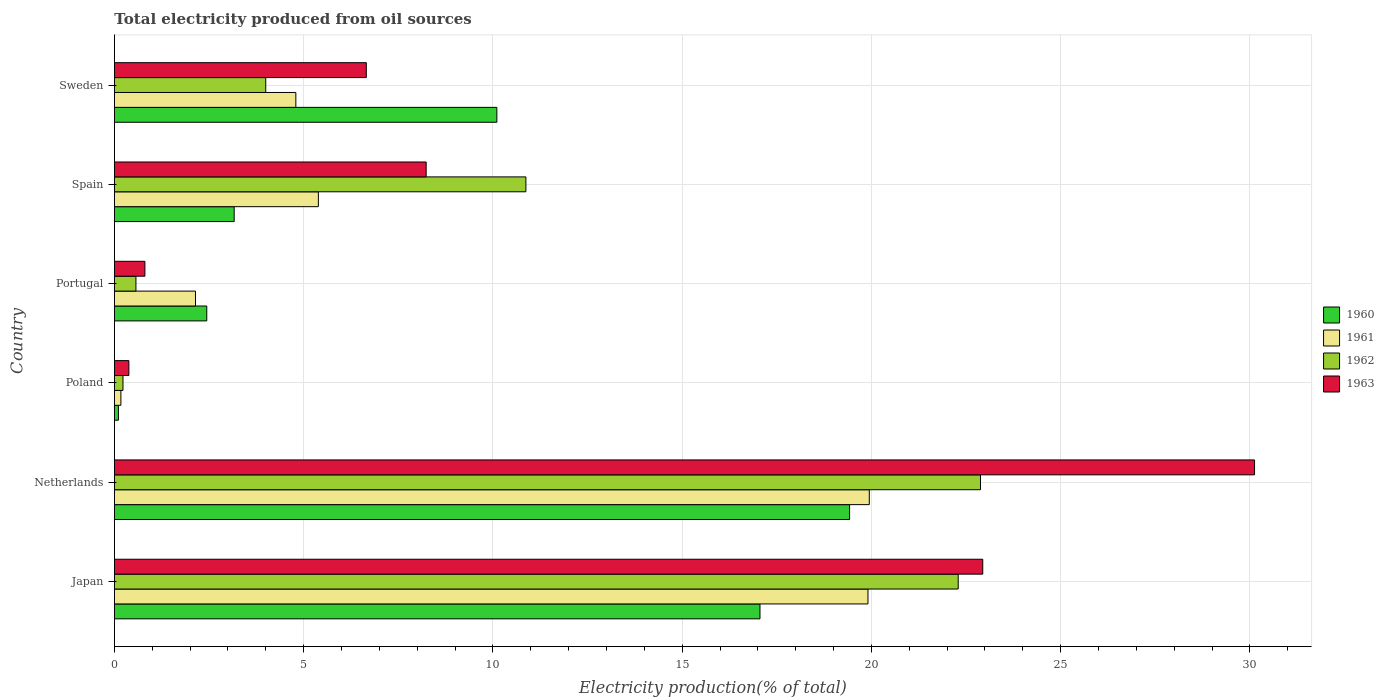How many different coloured bars are there?
Your response must be concise. 4. How many groups of bars are there?
Provide a short and direct response. 6. How many bars are there on the 4th tick from the top?
Give a very brief answer. 4. How many bars are there on the 2nd tick from the bottom?
Make the answer very short. 4. What is the label of the 4th group of bars from the top?
Keep it short and to the point. Poland. What is the total electricity produced in 1962 in Poland?
Your response must be concise. 0.23. Across all countries, what is the maximum total electricity produced in 1962?
Make the answer very short. 22.88. Across all countries, what is the minimum total electricity produced in 1962?
Give a very brief answer. 0.23. What is the total total electricity produced in 1960 in the graph?
Give a very brief answer. 52.29. What is the difference between the total electricity produced in 1960 in Netherlands and that in Portugal?
Keep it short and to the point. 16.98. What is the difference between the total electricity produced in 1963 in Japan and the total electricity produced in 1961 in Portugal?
Offer a very short reply. 20.8. What is the average total electricity produced in 1960 per country?
Offer a terse response. 8.72. What is the difference between the total electricity produced in 1962 and total electricity produced in 1963 in Spain?
Make the answer very short. 2.63. What is the ratio of the total electricity produced in 1962 in Japan to that in Portugal?
Provide a short and direct response. 39.24. Is the difference between the total electricity produced in 1962 in Japan and Portugal greater than the difference between the total electricity produced in 1963 in Japan and Portugal?
Your answer should be compact. No. What is the difference between the highest and the second highest total electricity produced in 1960?
Your answer should be compact. 2.37. What is the difference between the highest and the lowest total electricity produced in 1961?
Provide a short and direct response. 19.77. Is the sum of the total electricity produced in 1963 in Portugal and Spain greater than the maximum total electricity produced in 1962 across all countries?
Keep it short and to the point. No. Is it the case that in every country, the sum of the total electricity produced in 1962 and total electricity produced in 1961 is greater than the total electricity produced in 1960?
Ensure brevity in your answer.  No. How many bars are there?
Offer a terse response. 24. Are the values on the major ticks of X-axis written in scientific E-notation?
Your response must be concise. No. Does the graph contain any zero values?
Provide a short and direct response. No. Where does the legend appear in the graph?
Offer a very short reply. Center right. How many legend labels are there?
Give a very brief answer. 4. What is the title of the graph?
Your response must be concise. Total electricity produced from oil sources. What is the label or title of the Y-axis?
Your response must be concise. Country. What is the Electricity production(% of total) of 1960 in Japan?
Your answer should be compact. 17.06. What is the Electricity production(% of total) of 1961 in Japan?
Provide a succinct answer. 19.91. What is the Electricity production(% of total) of 1962 in Japan?
Provide a succinct answer. 22.29. What is the Electricity production(% of total) of 1963 in Japan?
Provide a short and direct response. 22.94. What is the Electricity production(% of total) in 1960 in Netherlands?
Your answer should be very brief. 19.42. What is the Electricity production(% of total) in 1961 in Netherlands?
Keep it short and to the point. 19.94. What is the Electricity production(% of total) in 1962 in Netherlands?
Ensure brevity in your answer.  22.88. What is the Electricity production(% of total) in 1963 in Netherlands?
Your answer should be compact. 30.12. What is the Electricity production(% of total) of 1960 in Poland?
Offer a very short reply. 0.11. What is the Electricity production(% of total) of 1961 in Poland?
Your answer should be very brief. 0.17. What is the Electricity production(% of total) in 1962 in Poland?
Keep it short and to the point. 0.23. What is the Electricity production(% of total) of 1963 in Poland?
Provide a succinct answer. 0.38. What is the Electricity production(% of total) of 1960 in Portugal?
Offer a terse response. 2.44. What is the Electricity production(% of total) in 1961 in Portugal?
Ensure brevity in your answer.  2.14. What is the Electricity production(% of total) of 1962 in Portugal?
Make the answer very short. 0.57. What is the Electricity production(% of total) in 1963 in Portugal?
Offer a very short reply. 0.81. What is the Electricity production(% of total) of 1960 in Spain?
Your answer should be very brief. 3.16. What is the Electricity production(% of total) of 1961 in Spain?
Provide a succinct answer. 5.39. What is the Electricity production(% of total) in 1962 in Spain?
Offer a terse response. 10.87. What is the Electricity production(% of total) in 1963 in Spain?
Your response must be concise. 8.24. What is the Electricity production(% of total) of 1960 in Sweden?
Provide a succinct answer. 10.1. What is the Electricity production(% of total) in 1961 in Sweden?
Make the answer very short. 4.79. What is the Electricity production(% of total) of 1962 in Sweden?
Give a very brief answer. 4. What is the Electricity production(% of total) of 1963 in Sweden?
Ensure brevity in your answer.  6.66. Across all countries, what is the maximum Electricity production(% of total) in 1960?
Your answer should be compact. 19.42. Across all countries, what is the maximum Electricity production(% of total) of 1961?
Give a very brief answer. 19.94. Across all countries, what is the maximum Electricity production(% of total) of 1962?
Keep it short and to the point. 22.88. Across all countries, what is the maximum Electricity production(% of total) in 1963?
Your answer should be compact. 30.12. Across all countries, what is the minimum Electricity production(% of total) of 1960?
Offer a terse response. 0.11. Across all countries, what is the minimum Electricity production(% of total) in 1961?
Your response must be concise. 0.17. Across all countries, what is the minimum Electricity production(% of total) of 1962?
Provide a short and direct response. 0.23. Across all countries, what is the minimum Electricity production(% of total) in 1963?
Provide a succinct answer. 0.38. What is the total Electricity production(% of total) of 1960 in the graph?
Your answer should be compact. 52.29. What is the total Electricity production(% of total) in 1961 in the graph?
Your response must be concise. 52.35. What is the total Electricity production(% of total) of 1962 in the graph?
Provide a short and direct response. 60.84. What is the total Electricity production(% of total) in 1963 in the graph?
Your answer should be compact. 69.14. What is the difference between the Electricity production(% of total) in 1960 in Japan and that in Netherlands?
Offer a terse response. -2.37. What is the difference between the Electricity production(% of total) of 1961 in Japan and that in Netherlands?
Your response must be concise. -0.04. What is the difference between the Electricity production(% of total) in 1962 in Japan and that in Netherlands?
Your response must be concise. -0.59. What is the difference between the Electricity production(% of total) of 1963 in Japan and that in Netherlands?
Your response must be concise. -7.18. What is the difference between the Electricity production(% of total) in 1960 in Japan and that in Poland?
Ensure brevity in your answer.  16.95. What is the difference between the Electricity production(% of total) in 1961 in Japan and that in Poland?
Offer a terse response. 19.74. What is the difference between the Electricity production(% of total) of 1962 in Japan and that in Poland?
Ensure brevity in your answer.  22.07. What is the difference between the Electricity production(% of total) of 1963 in Japan and that in Poland?
Ensure brevity in your answer.  22.56. What is the difference between the Electricity production(% of total) in 1960 in Japan and that in Portugal?
Ensure brevity in your answer.  14.62. What is the difference between the Electricity production(% of total) in 1961 in Japan and that in Portugal?
Give a very brief answer. 17.77. What is the difference between the Electricity production(% of total) of 1962 in Japan and that in Portugal?
Your response must be concise. 21.73. What is the difference between the Electricity production(% of total) of 1963 in Japan and that in Portugal?
Offer a terse response. 22.14. What is the difference between the Electricity production(% of total) in 1960 in Japan and that in Spain?
Your answer should be very brief. 13.89. What is the difference between the Electricity production(% of total) of 1961 in Japan and that in Spain?
Give a very brief answer. 14.52. What is the difference between the Electricity production(% of total) in 1962 in Japan and that in Spain?
Offer a very short reply. 11.42. What is the difference between the Electricity production(% of total) in 1963 in Japan and that in Spain?
Your answer should be very brief. 14.71. What is the difference between the Electricity production(% of total) in 1960 in Japan and that in Sweden?
Offer a very short reply. 6.95. What is the difference between the Electricity production(% of total) of 1961 in Japan and that in Sweden?
Your response must be concise. 15.12. What is the difference between the Electricity production(% of total) of 1962 in Japan and that in Sweden?
Provide a short and direct response. 18.3. What is the difference between the Electricity production(% of total) in 1963 in Japan and that in Sweden?
Your answer should be very brief. 16.29. What is the difference between the Electricity production(% of total) in 1960 in Netherlands and that in Poland?
Keep it short and to the point. 19.32. What is the difference between the Electricity production(% of total) in 1961 in Netherlands and that in Poland?
Provide a succinct answer. 19.77. What is the difference between the Electricity production(% of total) in 1962 in Netherlands and that in Poland?
Your answer should be compact. 22.66. What is the difference between the Electricity production(% of total) in 1963 in Netherlands and that in Poland?
Provide a succinct answer. 29.74. What is the difference between the Electricity production(% of total) of 1960 in Netherlands and that in Portugal?
Your answer should be compact. 16.98. What is the difference between the Electricity production(% of total) in 1961 in Netherlands and that in Portugal?
Make the answer very short. 17.8. What is the difference between the Electricity production(% of total) in 1962 in Netherlands and that in Portugal?
Give a very brief answer. 22.31. What is the difference between the Electricity production(% of total) in 1963 in Netherlands and that in Portugal?
Offer a terse response. 29.32. What is the difference between the Electricity production(% of total) in 1960 in Netherlands and that in Spain?
Offer a very short reply. 16.26. What is the difference between the Electricity production(% of total) in 1961 in Netherlands and that in Spain?
Offer a very short reply. 14.56. What is the difference between the Electricity production(% of total) in 1962 in Netherlands and that in Spain?
Offer a very short reply. 12.01. What is the difference between the Electricity production(% of total) of 1963 in Netherlands and that in Spain?
Your answer should be compact. 21.89. What is the difference between the Electricity production(% of total) in 1960 in Netherlands and that in Sweden?
Give a very brief answer. 9.32. What is the difference between the Electricity production(% of total) of 1961 in Netherlands and that in Sweden?
Offer a terse response. 15.15. What is the difference between the Electricity production(% of total) of 1962 in Netherlands and that in Sweden?
Your response must be concise. 18.88. What is the difference between the Electricity production(% of total) in 1963 in Netherlands and that in Sweden?
Offer a terse response. 23.47. What is the difference between the Electricity production(% of total) of 1960 in Poland and that in Portugal?
Your answer should be compact. -2.33. What is the difference between the Electricity production(% of total) of 1961 in Poland and that in Portugal?
Provide a succinct answer. -1.97. What is the difference between the Electricity production(% of total) in 1962 in Poland and that in Portugal?
Provide a succinct answer. -0.34. What is the difference between the Electricity production(% of total) in 1963 in Poland and that in Portugal?
Ensure brevity in your answer.  -0.42. What is the difference between the Electricity production(% of total) in 1960 in Poland and that in Spain?
Your response must be concise. -3.06. What is the difference between the Electricity production(% of total) in 1961 in Poland and that in Spain?
Give a very brief answer. -5.22. What is the difference between the Electricity production(% of total) of 1962 in Poland and that in Spain?
Your answer should be compact. -10.64. What is the difference between the Electricity production(% of total) in 1963 in Poland and that in Spain?
Provide a short and direct response. -7.85. What is the difference between the Electricity production(% of total) in 1960 in Poland and that in Sweden?
Your answer should be very brief. -10. What is the difference between the Electricity production(% of total) of 1961 in Poland and that in Sweden?
Give a very brief answer. -4.62. What is the difference between the Electricity production(% of total) of 1962 in Poland and that in Sweden?
Your answer should be compact. -3.77. What is the difference between the Electricity production(% of total) in 1963 in Poland and that in Sweden?
Offer a terse response. -6.27. What is the difference between the Electricity production(% of total) in 1960 in Portugal and that in Spain?
Ensure brevity in your answer.  -0.72. What is the difference between the Electricity production(% of total) in 1961 in Portugal and that in Spain?
Offer a very short reply. -3.25. What is the difference between the Electricity production(% of total) in 1962 in Portugal and that in Spain?
Provide a short and direct response. -10.3. What is the difference between the Electricity production(% of total) in 1963 in Portugal and that in Spain?
Your answer should be very brief. -7.43. What is the difference between the Electricity production(% of total) in 1960 in Portugal and that in Sweden?
Provide a succinct answer. -7.66. What is the difference between the Electricity production(% of total) in 1961 in Portugal and that in Sweden?
Your answer should be compact. -2.65. What is the difference between the Electricity production(% of total) in 1962 in Portugal and that in Sweden?
Give a very brief answer. -3.43. What is the difference between the Electricity production(% of total) in 1963 in Portugal and that in Sweden?
Offer a very short reply. -5.85. What is the difference between the Electricity production(% of total) in 1960 in Spain and that in Sweden?
Make the answer very short. -6.94. What is the difference between the Electricity production(% of total) in 1961 in Spain and that in Sweden?
Your answer should be very brief. 0.6. What is the difference between the Electricity production(% of total) in 1962 in Spain and that in Sweden?
Give a very brief answer. 6.87. What is the difference between the Electricity production(% of total) in 1963 in Spain and that in Sweden?
Ensure brevity in your answer.  1.58. What is the difference between the Electricity production(% of total) in 1960 in Japan and the Electricity production(% of total) in 1961 in Netherlands?
Offer a very short reply. -2.89. What is the difference between the Electricity production(% of total) of 1960 in Japan and the Electricity production(% of total) of 1962 in Netherlands?
Offer a very short reply. -5.83. What is the difference between the Electricity production(% of total) in 1960 in Japan and the Electricity production(% of total) in 1963 in Netherlands?
Your answer should be very brief. -13.07. What is the difference between the Electricity production(% of total) in 1961 in Japan and the Electricity production(% of total) in 1962 in Netherlands?
Ensure brevity in your answer.  -2.97. What is the difference between the Electricity production(% of total) in 1961 in Japan and the Electricity production(% of total) in 1963 in Netherlands?
Offer a very short reply. -10.21. What is the difference between the Electricity production(% of total) of 1962 in Japan and the Electricity production(% of total) of 1963 in Netherlands?
Your answer should be very brief. -7.83. What is the difference between the Electricity production(% of total) of 1960 in Japan and the Electricity production(% of total) of 1961 in Poland?
Your answer should be compact. 16.89. What is the difference between the Electricity production(% of total) of 1960 in Japan and the Electricity production(% of total) of 1962 in Poland?
Keep it short and to the point. 16.83. What is the difference between the Electricity production(% of total) of 1960 in Japan and the Electricity production(% of total) of 1963 in Poland?
Provide a short and direct response. 16.67. What is the difference between the Electricity production(% of total) in 1961 in Japan and the Electricity production(% of total) in 1962 in Poland?
Your answer should be very brief. 19.68. What is the difference between the Electricity production(% of total) of 1961 in Japan and the Electricity production(% of total) of 1963 in Poland?
Your answer should be compact. 19.53. What is the difference between the Electricity production(% of total) in 1962 in Japan and the Electricity production(% of total) in 1963 in Poland?
Make the answer very short. 21.91. What is the difference between the Electricity production(% of total) in 1960 in Japan and the Electricity production(% of total) in 1961 in Portugal?
Keep it short and to the point. 14.91. What is the difference between the Electricity production(% of total) of 1960 in Japan and the Electricity production(% of total) of 1962 in Portugal?
Provide a short and direct response. 16.49. What is the difference between the Electricity production(% of total) in 1960 in Japan and the Electricity production(% of total) in 1963 in Portugal?
Ensure brevity in your answer.  16.25. What is the difference between the Electricity production(% of total) of 1961 in Japan and the Electricity production(% of total) of 1962 in Portugal?
Provide a succinct answer. 19.34. What is the difference between the Electricity production(% of total) of 1961 in Japan and the Electricity production(% of total) of 1963 in Portugal?
Provide a succinct answer. 19.1. What is the difference between the Electricity production(% of total) in 1962 in Japan and the Electricity production(% of total) in 1963 in Portugal?
Your answer should be compact. 21.49. What is the difference between the Electricity production(% of total) in 1960 in Japan and the Electricity production(% of total) in 1961 in Spain?
Keep it short and to the point. 11.67. What is the difference between the Electricity production(% of total) of 1960 in Japan and the Electricity production(% of total) of 1962 in Spain?
Ensure brevity in your answer.  6.19. What is the difference between the Electricity production(% of total) in 1960 in Japan and the Electricity production(% of total) in 1963 in Spain?
Your answer should be compact. 8.82. What is the difference between the Electricity production(% of total) in 1961 in Japan and the Electricity production(% of total) in 1962 in Spain?
Make the answer very short. 9.04. What is the difference between the Electricity production(% of total) of 1961 in Japan and the Electricity production(% of total) of 1963 in Spain?
Give a very brief answer. 11.67. What is the difference between the Electricity production(% of total) in 1962 in Japan and the Electricity production(% of total) in 1963 in Spain?
Provide a short and direct response. 14.06. What is the difference between the Electricity production(% of total) of 1960 in Japan and the Electricity production(% of total) of 1961 in Sweden?
Your answer should be compact. 12.26. What is the difference between the Electricity production(% of total) of 1960 in Japan and the Electricity production(% of total) of 1962 in Sweden?
Provide a succinct answer. 13.06. What is the difference between the Electricity production(% of total) in 1960 in Japan and the Electricity production(% of total) in 1963 in Sweden?
Your answer should be compact. 10.4. What is the difference between the Electricity production(% of total) of 1961 in Japan and the Electricity production(% of total) of 1962 in Sweden?
Your answer should be very brief. 15.91. What is the difference between the Electricity production(% of total) in 1961 in Japan and the Electricity production(% of total) in 1963 in Sweden?
Your answer should be very brief. 13.25. What is the difference between the Electricity production(% of total) of 1962 in Japan and the Electricity production(% of total) of 1963 in Sweden?
Provide a succinct answer. 15.64. What is the difference between the Electricity production(% of total) of 1960 in Netherlands and the Electricity production(% of total) of 1961 in Poland?
Offer a very short reply. 19.25. What is the difference between the Electricity production(% of total) in 1960 in Netherlands and the Electricity production(% of total) in 1962 in Poland?
Give a very brief answer. 19.2. What is the difference between the Electricity production(% of total) of 1960 in Netherlands and the Electricity production(% of total) of 1963 in Poland?
Make the answer very short. 19.04. What is the difference between the Electricity production(% of total) of 1961 in Netherlands and the Electricity production(% of total) of 1962 in Poland?
Ensure brevity in your answer.  19.72. What is the difference between the Electricity production(% of total) of 1961 in Netherlands and the Electricity production(% of total) of 1963 in Poland?
Your answer should be very brief. 19.56. What is the difference between the Electricity production(% of total) in 1962 in Netherlands and the Electricity production(% of total) in 1963 in Poland?
Your answer should be very brief. 22.5. What is the difference between the Electricity production(% of total) of 1960 in Netherlands and the Electricity production(% of total) of 1961 in Portugal?
Provide a succinct answer. 17.28. What is the difference between the Electricity production(% of total) of 1960 in Netherlands and the Electricity production(% of total) of 1962 in Portugal?
Provide a succinct answer. 18.86. What is the difference between the Electricity production(% of total) of 1960 in Netherlands and the Electricity production(% of total) of 1963 in Portugal?
Keep it short and to the point. 18.62. What is the difference between the Electricity production(% of total) of 1961 in Netherlands and the Electricity production(% of total) of 1962 in Portugal?
Provide a succinct answer. 19.38. What is the difference between the Electricity production(% of total) in 1961 in Netherlands and the Electricity production(% of total) in 1963 in Portugal?
Your answer should be very brief. 19.14. What is the difference between the Electricity production(% of total) in 1962 in Netherlands and the Electricity production(% of total) in 1963 in Portugal?
Offer a very short reply. 22.08. What is the difference between the Electricity production(% of total) of 1960 in Netherlands and the Electricity production(% of total) of 1961 in Spain?
Your answer should be compact. 14.04. What is the difference between the Electricity production(% of total) of 1960 in Netherlands and the Electricity production(% of total) of 1962 in Spain?
Ensure brevity in your answer.  8.55. What is the difference between the Electricity production(% of total) of 1960 in Netherlands and the Electricity production(% of total) of 1963 in Spain?
Your answer should be very brief. 11.19. What is the difference between the Electricity production(% of total) of 1961 in Netherlands and the Electricity production(% of total) of 1962 in Spain?
Your answer should be compact. 9.07. What is the difference between the Electricity production(% of total) in 1961 in Netherlands and the Electricity production(% of total) in 1963 in Spain?
Provide a short and direct response. 11.71. What is the difference between the Electricity production(% of total) in 1962 in Netherlands and the Electricity production(% of total) in 1963 in Spain?
Give a very brief answer. 14.65. What is the difference between the Electricity production(% of total) of 1960 in Netherlands and the Electricity production(% of total) of 1961 in Sweden?
Provide a succinct answer. 14.63. What is the difference between the Electricity production(% of total) of 1960 in Netherlands and the Electricity production(% of total) of 1962 in Sweden?
Your answer should be very brief. 15.43. What is the difference between the Electricity production(% of total) of 1960 in Netherlands and the Electricity production(% of total) of 1963 in Sweden?
Give a very brief answer. 12.77. What is the difference between the Electricity production(% of total) in 1961 in Netherlands and the Electricity production(% of total) in 1962 in Sweden?
Your answer should be very brief. 15.95. What is the difference between the Electricity production(% of total) of 1961 in Netherlands and the Electricity production(% of total) of 1963 in Sweden?
Offer a terse response. 13.29. What is the difference between the Electricity production(% of total) in 1962 in Netherlands and the Electricity production(% of total) in 1963 in Sweden?
Give a very brief answer. 16.23. What is the difference between the Electricity production(% of total) in 1960 in Poland and the Electricity production(% of total) in 1961 in Portugal?
Keep it short and to the point. -2.04. What is the difference between the Electricity production(% of total) in 1960 in Poland and the Electricity production(% of total) in 1962 in Portugal?
Provide a short and direct response. -0.46. What is the difference between the Electricity production(% of total) in 1960 in Poland and the Electricity production(% of total) in 1963 in Portugal?
Give a very brief answer. -0.7. What is the difference between the Electricity production(% of total) in 1961 in Poland and the Electricity production(% of total) in 1962 in Portugal?
Your answer should be very brief. -0.4. What is the difference between the Electricity production(% of total) in 1961 in Poland and the Electricity production(% of total) in 1963 in Portugal?
Make the answer very short. -0.63. What is the difference between the Electricity production(% of total) of 1962 in Poland and the Electricity production(% of total) of 1963 in Portugal?
Keep it short and to the point. -0.58. What is the difference between the Electricity production(% of total) in 1960 in Poland and the Electricity production(% of total) in 1961 in Spain?
Keep it short and to the point. -5.28. What is the difference between the Electricity production(% of total) in 1960 in Poland and the Electricity production(% of total) in 1962 in Spain?
Offer a very short reply. -10.77. What is the difference between the Electricity production(% of total) in 1960 in Poland and the Electricity production(% of total) in 1963 in Spain?
Give a very brief answer. -8.13. What is the difference between the Electricity production(% of total) of 1961 in Poland and the Electricity production(% of total) of 1962 in Spain?
Ensure brevity in your answer.  -10.7. What is the difference between the Electricity production(% of total) in 1961 in Poland and the Electricity production(% of total) in 1963 in Spain?
Make the answer very short. -8.07. What is the difference between the Electricity production(% of total) of 1962 in Poland and the Electricity production(% of total) of 1963 in Spain?
Your answer should be compact. -8.01. What is the difference between the Electricity production(% of total) in 1960 in Poland and the Electricity production(% of total) in 1961 in Sweden?
Your answer should be very brief. -4.69. What is the difference between the Electricity production(% of total) in 1960 in Poland and the Electricity production(% of total) in 1962 in Sweden?
Your answer should be very brief. -3.89. What is the difference between the Electricity production(% of total) in 1960 in Poland and the Electricity production(% of total) in 1963 in Sweden?
Offer a very short reply. -6.55. What is the difference between the Electricity production(% of total) of 1961 in Poland and the Electricity production(% of total) of 1962 in Sweden?
Give a very brief answer. -3.83. What is the difference between the Electricity production(% of total) in 1961 in Poland and the Electricity production(% of total) in 1963 in Sweden?
Make the answer very short. -6.48. What is the difference between the Electricity production(% of total) of 1962 in Poland and the Electricity production(% of total) of 1963 in Sweden?
Your answer should be compact. -6.43. What is the difference between the Electricity production(% of total) in 1960 in Portugal and the Electricity production(% of total) in 1961 in Spain?
Offer a terse response. -2.95. What is the difference between the Electricity production(% of total) of 1960 in Portugal and the Electricity production(% of total) of 1962 in Spain?
Provide a succinct answer. -8.43. What is the difference between the Electricity production(% of total) of 1960 in Portugal and the Electricity production(% of total) of 1963 in Spain?
Your response must be concise. -5.8. What is the difference between the Electricity production(% of total) in 1961 in Portugal and the Electricity production(% of total) in 1962 in Spain?
Make the answer very short. -8.73. What is the difference between the Electricity production(% of total) of 1961 in Portugal and the Electricity production(% of total) of 1963 in Spain?
Offer a terse response. -6.09. What is the difference between the Electricity production(% of total) of 1962 in Portugal and the Electricity production(% of total) of 1963 in Spain?
Keep it short and to the point. -7.67. What is the difference between the Electricity production(% of total) of 1960 in Portugal and the Electricity production(% of total) of 1961 in Sweden?
Your answer should be very brief. -2.35. What is the difference between the Electricity production(% of total) in 1960 in Portugal and the Electricity production(% of total) in 1962 in Sweden?
Provide a succinct answer. -1.56. What is the difference between the Electricity production(% of total) in 1960 in Portugal and the Electricity production(% of total) in 1963 in Sweden?
Your answer should be compact. -4.22. What is the difference between the Electricity production(% of total) in 1961 in Portugal and the Electricity production(% of total) in 1962 in Sweden?
Your response must be concise. -1.86. What is the difference between the Electricity production(% of total) of 1961 in Portugal and the Electricity production(% of total) of 1963 in Sweden?
Your answer should be very brief. -4.51. What is the difference between the Electricity production(% of total) in 1962 in Portugal and the Electricity production(% of total) in 1963 in Sweden?
Provide a succinct answer. -6.09. What is the difference between the Electricity production(% of total) of 1960 in Spain and the Electricity production(% of total) of 1961 in Sweden?
Make the answer very short. -1.63. What is the difference between the Electricity production(% of total) in 1960 in Spain and the Electricity production(% of total) in 1962 in Sweden?
Provide a succinct answer. -0.83. What is the difference between the Electricity production(% of total) of 1960 in Spain and the Electricity production(% of total) of 1963 in Sweden?
Your answer should be compact. -3.49. What is the difference between the Electricity production(% of total) of 1961 in Spain and the Electricity production(% of total) of 1962 in Sweden?
Your answer should be very brief. 1.39. What is the difference between the Electricity production(% of total) of 1961 in Spain and the Electricity production(% of total) of 1963 in Sweden?
Give a very brief answer. -1.27. What is the difference between the Electricity production(% of total) of 1962 in Spain and the Electricity production(% of total) of 1963 in Sweden?
Make the answer very short. 4.22. What is the average Electricity production(% of total) in 1960 per country?
Offer a very short reply. 8.72. What is the average Electricity production(% of total) of 1961 per country?
Give a very brief answer. 8.72. What is the average Electricity production(% of total) of 1962 per country?
Make the answer very short. 10.14. What is the average Electricity production(% of total) of 1963 per country?
Offer a terse response. 11.52. What is the difference between the Electricity production(% of total) of 1960 and Electricity production(% of total) of 1961 in Japan?
Offer a terse response. -2.85. What is the difference between the Electricity production(% of total) of 1960 and Electricity production(% of total) of 1962 in Japan?
Your answer should be compact. -5.24. What is the difference between the Electricity production(% of total) in 1960 and Electricity production(% of total) in 1963 in Japan?
Your answer should be very brief. -5.89. What is the difference between the Electricity production(% of total) of 1961 and Electricity production(% of total) of 1962 in Japan?
Provide a short and direct response. -2.38. What is the difference between the Electricity production(% of total) of 1961 and Electricity production(% of total) of 1963 in Japan?
Provide a short and direct response. -3.03. What is the difference between the Electricity production(% of total) in 1962 and Electricity production(% of total) in 1963 in Japan?
Ensure brevity in your answer.  -0.65. What is the difference between the Electricity production(% of total) in 1960 and Electricity production(% of total) in 1961 in Netherlands?
Provide a succinct answer. -0.52. What is the difference between the Electricity production(% of total) in 1960 and Electricity production(% of total) in 1962 in Netherlands?
Keep it short and to the point. -3.46. What is the difference between the Electricity production(% of total) of 1960 and Electricity production(% of total) of 1963 in Netherlands?
Your answer should be very brief. -10.7. What is the difference between the Electricity production(% of total) in 1961 and Electricity production(% of total) in 1962 in Netherlands?
Provide a succinct answer. -2.94. What is the difference between the Electricity production(% of total) of 1961 and Electricity production(% of total) of 1963 in Netherlands?
Give a very brief answer. -10.18. What is the difference between the Electricity production(% of total) of 1962 and Electricity production(% of total) of 1963 in Netherlands?
Your response must be concise. -7.24. What is the difference between the Electricity production(% of total) in 1960 and Electricity production(% of total) in 1961 in Poland?
Provide a short and direct response. -0.06. What is the difference between the Electricity production(% of total) of 1960 and Electricity production(% of total) of 1962 in Poland?
Give a very brief answer. -0.12. What is the difference between the Electricity production(% of total) of 1960 and Electricity production(% of total) of 1963 in Poland?
Your answer should be very brief. -0.28. What is the difference between the Electricity production(% of total) of 1961 and Electricity production(% of total) of 1962 in Poland?
Give a very brief answer. -0.06. What is the difference between the Electricity production(% of total) in 1961 and Electricity production(% of total) in 1963 in Poland?
Give a very brief answer. -0.21. What is the difference between the Electricity production(% of total) in 1962 and Electricity production(% of total) in 1963 in Poland?
Ensure brevity in your answer.  -0.16. What is the difference between the Electricity production(% of total) of 1960 and Electricity production(% of total) of 1961 in Portugal?
Your answer should be compact. 0.3. What is the difference between the Electricity production(% of total) in 1960 and Electricity production(% of total) in 1962 in Portugal?
Make the answer very short. 1.87. What is the difference between the Electricity production(% of total) of 1960 and Electricity production(% of total) of 1963 in Portugal?
Ensure brevity in your answer.  1.63. What is the difference between the Electricity production(% of total) of 1961 and Electricity production(% of total) of 1962 in Portugal?
Offer a very short reply. 1.57. What is the difference between the Electricity production(% of total) in 1961 and Electricity production(% of total) in 1963 in Portugal?
Make the answer very short. 1.34. What is the difference between the Electricity production(% of total) in 1962 and Electricity production(% of total) in 1963 in Portugal?
Your answer should be very brief. -0.24. What is the difference between the Electricity production(% of total) in 1960 and Electricity production(% of total) in 1961 in Spain?
Your answer should be compact. -2.22. What is the difference between the Electricity production(% of total) in 1960 and Electricity production(% of total) in 1962 in Spain?
Keep it short and to the point. -7.71. What is the difference between the Electricity production(% of total) of 1960 and Electricity production(% of total) of 1963 in Spain?
Your response must be concise. -5.07. What is the difference between the Electricity production(% of total) in 1961 and Electricity production(% of total) in 1962 in Spain?
Ensure brevity in your answer.  -5.48. What is the difference between the Electricity production(% of total) in 1961 and Electricity production(% of total) in 1963 in Spain?
Make the answer very short. -2.85. What is the difference between the Electricity production(% of total) in 1962 and Electricity production(% of total) in 1963 in Spain?
Keep it short and to the point. 2.63. What is the difference between the Electricity production(% of total) of 1960 and Electricity production(% of total) of 1961 in Sweden?
Make the answer very short. 5.31. What is the difference between the Electricity production(% of total) in 1960 and Electricity production(% of total) in 1962 in Sweden?
Make the answer very short. 6.11. What is the difference between the Electricity production(% of total) of 1960 and Electricity production(% of total) of 1963 in Sweden?
Provide a succinct answer. 3.45. What is the difference between the Electricity production(% of total) of 1961 and Electricity production(% of total) of 1962 in Sweden?
Give a very brief answer. 0.8. What is the difference between the Electricity production(% of total) in 1961 and Electricity production(% of total) in 1963 in Sweden?
Provide a short and direct response. -1.86. What is the difference between the Electricity production(% of total) in 1962 and Electricity production(% of total) in 1963 in Sweden?
Your response must be concise. -2.66. What is the ratio of the Electricity production(% of total) in 1960 in Japan to that in Netherlands?
Offer a very short reply. 0.88. What is the ratio of the Electricity production(% of total) in 1961 in Japan to that in Netherlands?
Your answer should be very brief. 1. What is the ratio of the Electricity production(% of total) of 1962 in Japan to that in Netherlands?
Offer a terse response. 0.97. What is the ratio of the Electricity production(% of total) in 1963 in Japan to that in Netherlands?
Keep it short and to the point. 0.76. What is the ratio of the Electricity production(% of total) in 1960 in Japan to that in Poland?
Give a very brief answer. 161.11. What is the ratio of the Electricity production(% of total) of 1961 in Japan to that in Poland?
Your response must be concise. 116.7. What is the ratio of the Electricity production(% of total) of 1962 in Japan to that in Poland?
Provide a succinct answer. 98.55. What is the ratio of the Electricity production(% of total) in 1963 in Japan to that in Poland?
Your response must be concise. 60.11. What is the ratio of the Electricity production(% of total) in 1960 in Japan to that in Portugal?
Your response must be concise. 6.99. What is the ratio of the Electricity production(% of total) in 1961 in Japan to that in Portugal?
Give a very brief answer. 9.3. What is the ratio of the Electricity production(% of total) of 1962 in Japan to that in Portugal?
Provide a succinct answer. 39.24. What is the ratio of the Electricity production(% of total) in 1963 in Japan to that in Portugal?
Keep it short and to the point. 28.49. What is the ratio of the Electricity production(% of total) of 1960 in Japan to that in Spain?
Make the answer very short. 5.39. What is the ratio of the Electricity production(% of total) of 1961 in Japan to that in Spain?
Offer a very short reply. 3.69. What is the ratio of the Electricity production(% of total) in 1962 in Japan to that in Spain?
Ensure brevity in your answer.  2.05. What is the ratio of the Electricity production(% of total) of 1963 in Japan to that in Spain?
Offer a terse response. 2.79. What is the ratio of the Electricity production(% of total) in 1960 in Japan to that in Sweden?
Make the answer very short. 1.69. What is the ratio of the Electricity production(% of total) of 1961 in Japan to that in Sweden?
Keep it short and to the point. 4.15. What is the ratio of the Electricity production(% of total) in 1962 in Japan to that in Sweden?
Offer a very short reply. 5.58. What is the ratio of the Electricity production(% of total) of 1963 in Japan to that in Sweden?
Your answer should be compact. 3.45. What is the ratio of the Electricity production(% of total) in 1960 in Netherlands to that in Poland?
Your answer should be very brief. 183.47. What is the ratio of the Electricity production(% of total) in 1961 in Netherlands to that in Poland?
Your answer should be compact. 116.91. What is the ratio of the Electricity production(% of total) of 1962 in Netherlands to that in Poland?
Offer a terse response. 101.15. What is the ratio of the Electricity production(% of total) in 1963 in Netherlands to that in Poland?
Make the answer very short. 78.92. What is the ratio of the Electricity production(% of total) in 1960 in Netherlands to that in Portugal?
Your response must be concise. 7.96. What is the ratio of the Electricity production(% of total) of 1961 in Netherlands to that in Portugal?
Make the answer very short. 9.31. What is the ratio of the Electricity production(% of total) in 1962 in Netherlands to that in Portugal?
Your answer should be very brief. 40.27. What is the ratio of the Electricity production(% of total) in 1963 in Netherlands to that in Portugal?
Your answer should be very brief. 37.4. What is the ratio of the Electricity production(% of total) of 1960 in Netherlands to that in Spain?
Provide a succinct answer. 6.14. What is the ratio of the Electricity production(% of total) of 1961 in Netherlands to that in Spain?
Offer a terse response. 3.7. What is the ratio of the Electricity production(% of total) of 1962 in Netherlands to that in Spain?
Offer a very short reply. 2.1. What is the ratio of the Electricity production(% of total) in 1963 in Netherlands to that in Spain?
Give a very brief answer. 3.66. What is the ratio of the Electricity production(% of total) of 1960 in Netherlands to that in Sweden?
Make the answer very short. 1.92. What is the ratio of the Electricity production(% of total) in 1961 in Netherlands to that in Sweden?
Your answer should be very brief. 4.16. What is the ratio of the Electricity production(% of total) in 1962 in Netherlands to that in Sweden?
Your response must be concise. 5.72. What is the ratio of the Electricity production(% of total) of 1963 in Netherlands to that in Sweden?
Your answer should be very brief. 4.53. What is the ratio of the Electricity production(% of total) in 1960 in Poland to that in Portugal?
Provide a succinct answer. 0.04. What is the ratio of the Electricity production(% of total) of 1961 in Poland to that in Portugal?
Offer a very short reply. 0.08. What is the ratio of the Electricity production(% of total) of 1962 in Poland to that in Portugal?
Your answer should be compact. 0.4. What is the ratio of the Electricity production(% of total) in 1963 in Poland to that in Portugal?
Keep it short and to the point. 0.47. What is the ratio of the Electricity production(% of total) of 1960 in Poland to that in Spain?
Give a very brief answer. 0.03. What is the ratio of the Electricity production(% of total) of 1961 in Poland to that in Spain?
Offer a terse response. 0.03. What is the ratio of the Electricity production(% of total) of 1962 in Poland to that in Spain?
Make the answer very short. 0.02. What is the ratio of the Electricity production(% of total) of 1963 in Poland to that in Spain?
Ensure brevity in your answer.  0.05. What is the ratio of the Electricity production(% of total) of 1960 in Poland to that in Sweden?
Make the answer very short. 0.01. What is the ratio of the Electricity production(% of total) in 1961 in Poland to that in Sweden?
Your response must be concise. 0.04. What is the ratio of the Electricity production(% of total) of 1962 in Poland to that in Sweden?
Ensure brevity in your answer.  0.06. What is the ratio of the Electricity production(% of total) of 1963 in Poland to that in Sweden?
Your answer should be compact. 0.06. What is the ratio of the Electricity production(% of total) of 1960 in Portugal to that in Spain?
Keep it short and to the point. 0.77. What is the ratio of the Electricity production(% of total) of 1961 in Portugal to that in Spain?
Your response must be concise. 0.4. What is the ratio of the Electricity production(% of total) in 1962 in Portugal to that in Spain?
Keep it short and to the point. 0.05. What is the ratio of the Electricity production(% of total) in 1963 in Portugal to that in Spain?
Offer a very short reply. 0.1. What is the ratio of the Electricity production(% of total) of 1960 in Portugal to that in Sweden?
Your answer should be compact. 0.24. What is the ratio of the Electricity production(% of total) in 1961 in Portugal to that in Sweden?
Your response must be concise. 0.45. What is the ratio of the Electricity production(% of total) of 1962 in Portugal to that in Sweden?
Offer a very short reply. 0.14. What is the ratio of the Electricity production(% of total) of 1963 in Portugal to that in Sweden?
Your answer should be compact. 0.12. What is the ratio of the Electricity production(% of total) in 1960 in Spain to that in Sweden?
Offer a terse response. 0.31. What is the ratio of the Electricity production(% of total) in 1961 in Spain to that in Sweden?
Offer a very short reply. 1.12. What is the ratio of the Electricity production(% of total) in 1962 in Spain to that in Sweden?
Ensure brevity in your answer.  2.72. What is the ratio of the Electricity production(% of total) of 1963 in Spain to that in Sweden?
Provide a succinct answer. 1.24. What is the difference between the highest and the second highest Electricity production(% of total) in 1960?
Offer a terse response. 2.37. What is the difference between the highest and the second highest Electricity production(% of total) in 1961?
Provide a short and direct response. 0.04. What is the difference between the highest and the second highest Electricity production(% of total) of 1962?
Offer a very short reply. 0.59. What is the difference between the highest and the second highest Electricity production(% of total) in 1963?
Provide a succinct answer. 7.18. What is the difference between the highest and the lowest Electricity production(% of total) of 1960?
Give a very brief answer. 19.32. What is the difference between the highest and the lowest Electricity production(% of total) in 1961?
Keep it short and to the point. 19.77. What is the difference between the highest and the lowest Electricity production(% of total) in 1962?
Make the answer very short. 22.66. What is the difference between the highest and the lowest Electricity production(% of total) of 1963?
Your answer should be very brief. 29.74. 